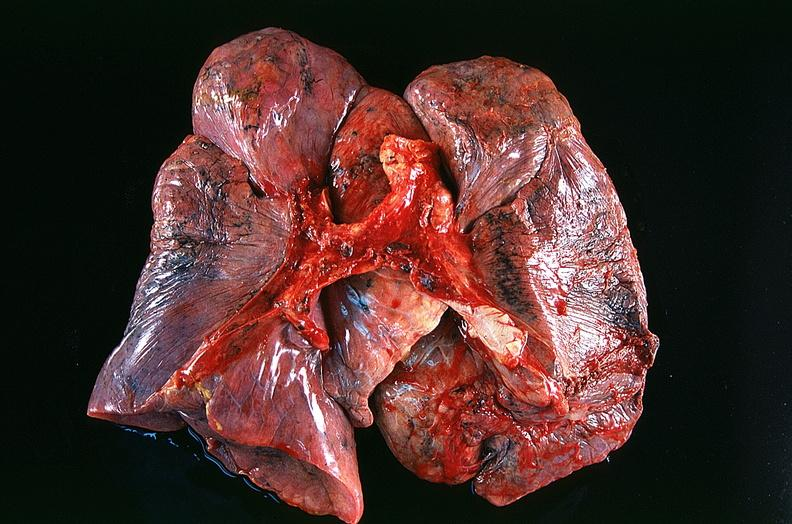what does this image show?
Answer the question using a single word or phrase. Lung 